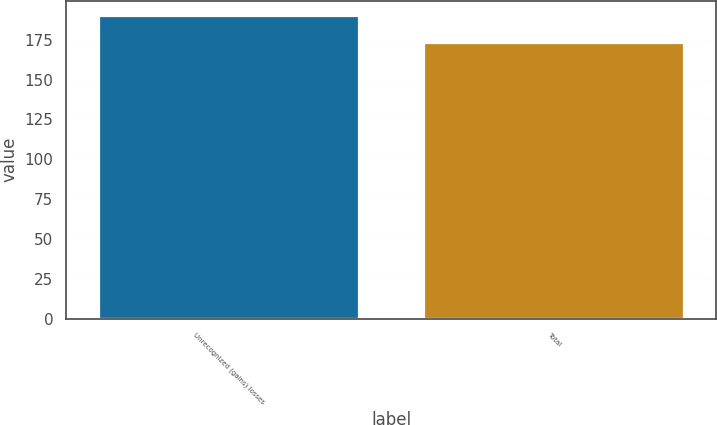<chart> <loc_0><loc_0><loc_500><loc_500><bar_chart><fcel>Unrecognized (gains) losses<fcel>Total<nl><fcel>190<fcel>173<nl></chart> 